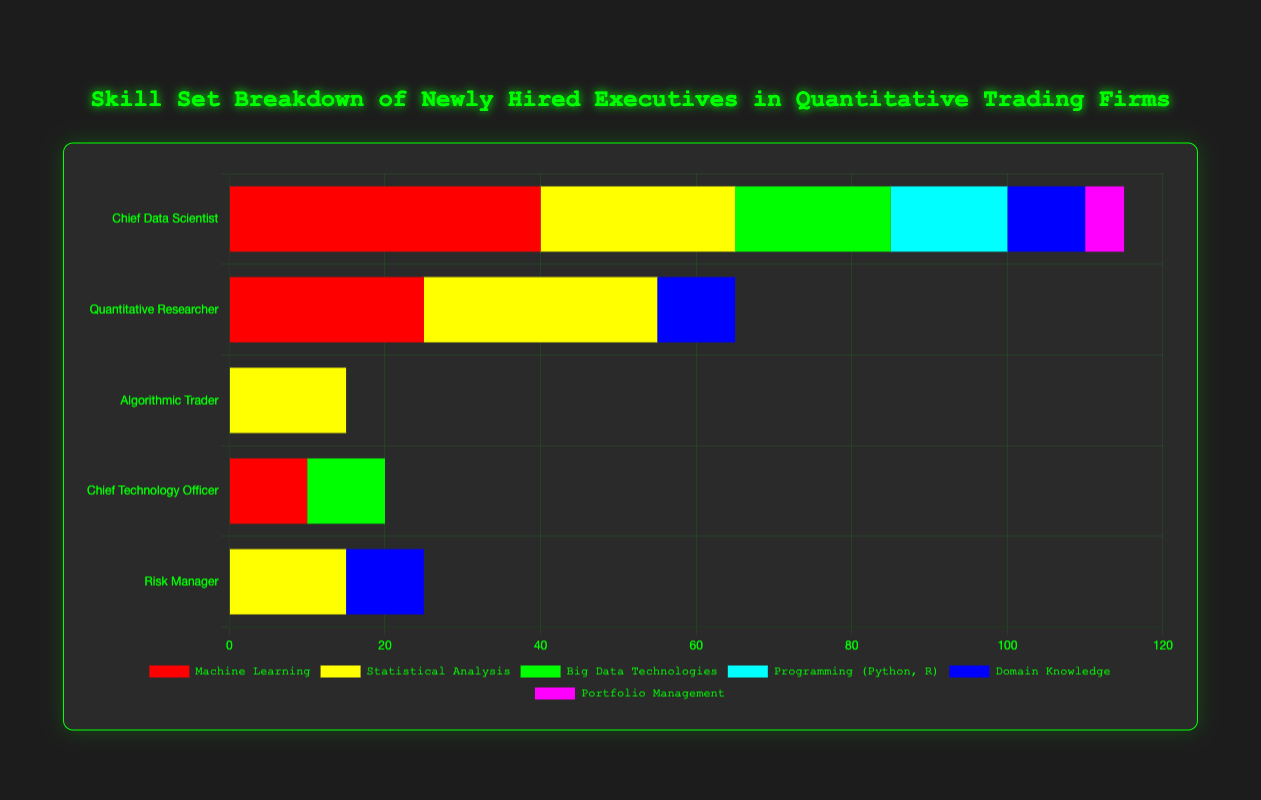How does the skill breakdown for the Chief Data Scientist compare to the Quantitative Researcher in terms of Machine Learning? The Chief Data Scientist has 40% for Machine Learning, while the Quantitative Researcher has 25%. This shows that the Chief Data Scientist emphasizes Machine Learning more.
Answer: The Chief Data Scientist has 15% more Machine Learning emphasis than the Quantitative Researcher What is the total percentage of skills related to programming (Python, R, C++, SQL) for the Algorithmic Trader? The Algorithmic Trader has 35% for Low-latency Programming (C++), 15% for Statistical Analysis, and 10% each for High-frequency Trading and Financial Instruments. Adding these gives: 35 + 15 + 10 + 10 = 70.
Answer: 70% Which role has the most diversified skill set, and how can you tell? The diversification of a skill set can be inferred by the number and even distribution of skills. The Quantitative Researcher and Chief Data Scientist both appear diversified, as their percentages are more evenly spread and they cover around 5-6 different skill areas. After observing the chart data, the Quantitative Researcher has a close balance across 6 skills.
Answer: Quantitative Researcher For the Chief Technology Officer, how do the contributions of Cloud Computing and Cybersecurity skills compare? For the Chief Technology Officer, Cloud Computing contributes 20%, and Cybersecurity contributes 20% as well. Both skills have an equal emphasis.
Answer: They are equal at 20% each Which skill is the least emphasized across all roles? Portfolio Management for Chief Data Scientist and High-frequency Trading for Algorithmic Trader both have 5% and 10% respectively. Since no other skill is lower, Portfolio Management is the least emphasized.
Answer: Portfolio Management (5%) What is the difference in emphasis on Data Technologies (both Big Data and Cloud Computing) between the Chief Data Scientist and the Chief Technology Officer? For the Chief Data Scientist, Big Data Technologies is 20%. For the Chief Technology Officer, Big Data Technologies is 10% and Cloud Computing is 20%. Summing for the CTO: 10 + 20 = 30. Thus, the CTO emphasizes 10% more on Data Technologies compared to the Chief Data Scientist.
Answer: 10% How does the Risk Manager emphasize skills in Financial Instruments compared to Regulatory Knowledge? Both Financial Instruments and Regulatory Knowledge for the Risk Manager have an emphasis of 20%.
Answer: They are emphasized equally at 20% In terms of percentages, how much more does the Chief Technology Officer emphasize System Architecture compared to Project Management? The Chief Technology Officer emphasizes System Architecture at 35% and Project Management at 15%. Calculating the difference: 35 - 15 = 20.
Answer: 20% Which skill is most prominently featured among all roles, and which role has the highest percentage in this skill? Risk Assessment is a prominent feature at 40% for the Risk Manager. Machine Learning is also highly rated at 40% for the Chief Data Scientist, but since our question is across all roles, Risk Assessment holds as the most prominent.
Answer: Risk Assessment (40%), Risk Manager 